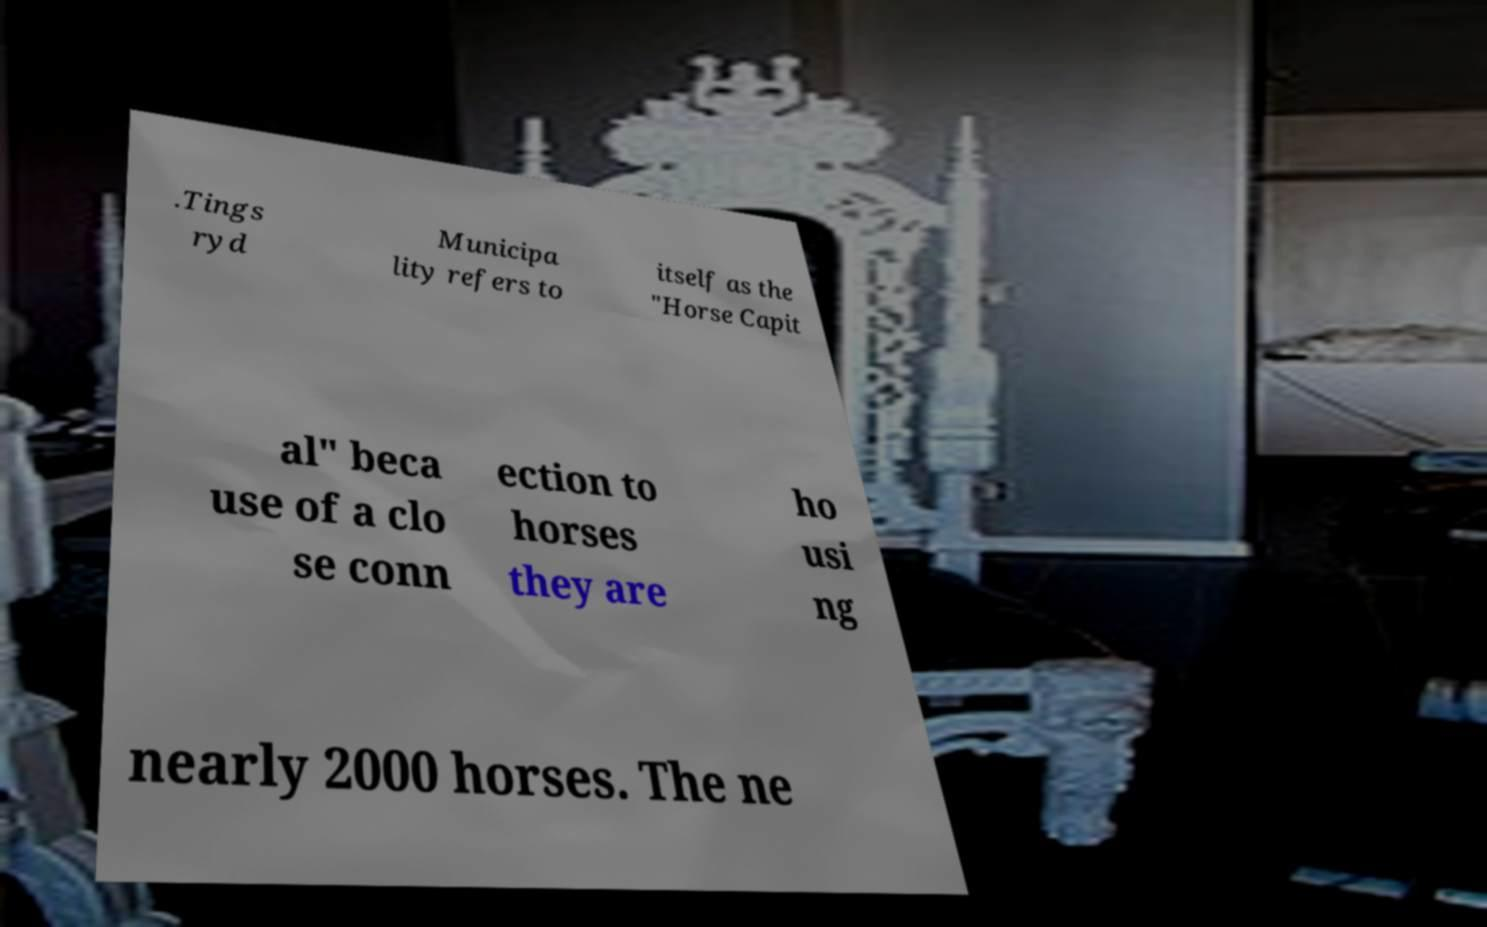There's text embedded in this image that I need extracted. Can you transcribe it verbatim? .Tings ryd Municipa lity refers to itself as the "Horse Capit al" beca use of a clo se conn ection to horses they are ho usi ng nearly 2000 horses. The ne 